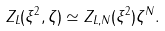Convert formula to latex. <formula><loc_0><loc_0><loc_500><loc_500>Z _ { L } ( \xi ^ { 2 } , \zeta ) \simeq Z _ { L , N } ( \xi ^ { 2 } ) \zeta ^ { N } .</formula> 